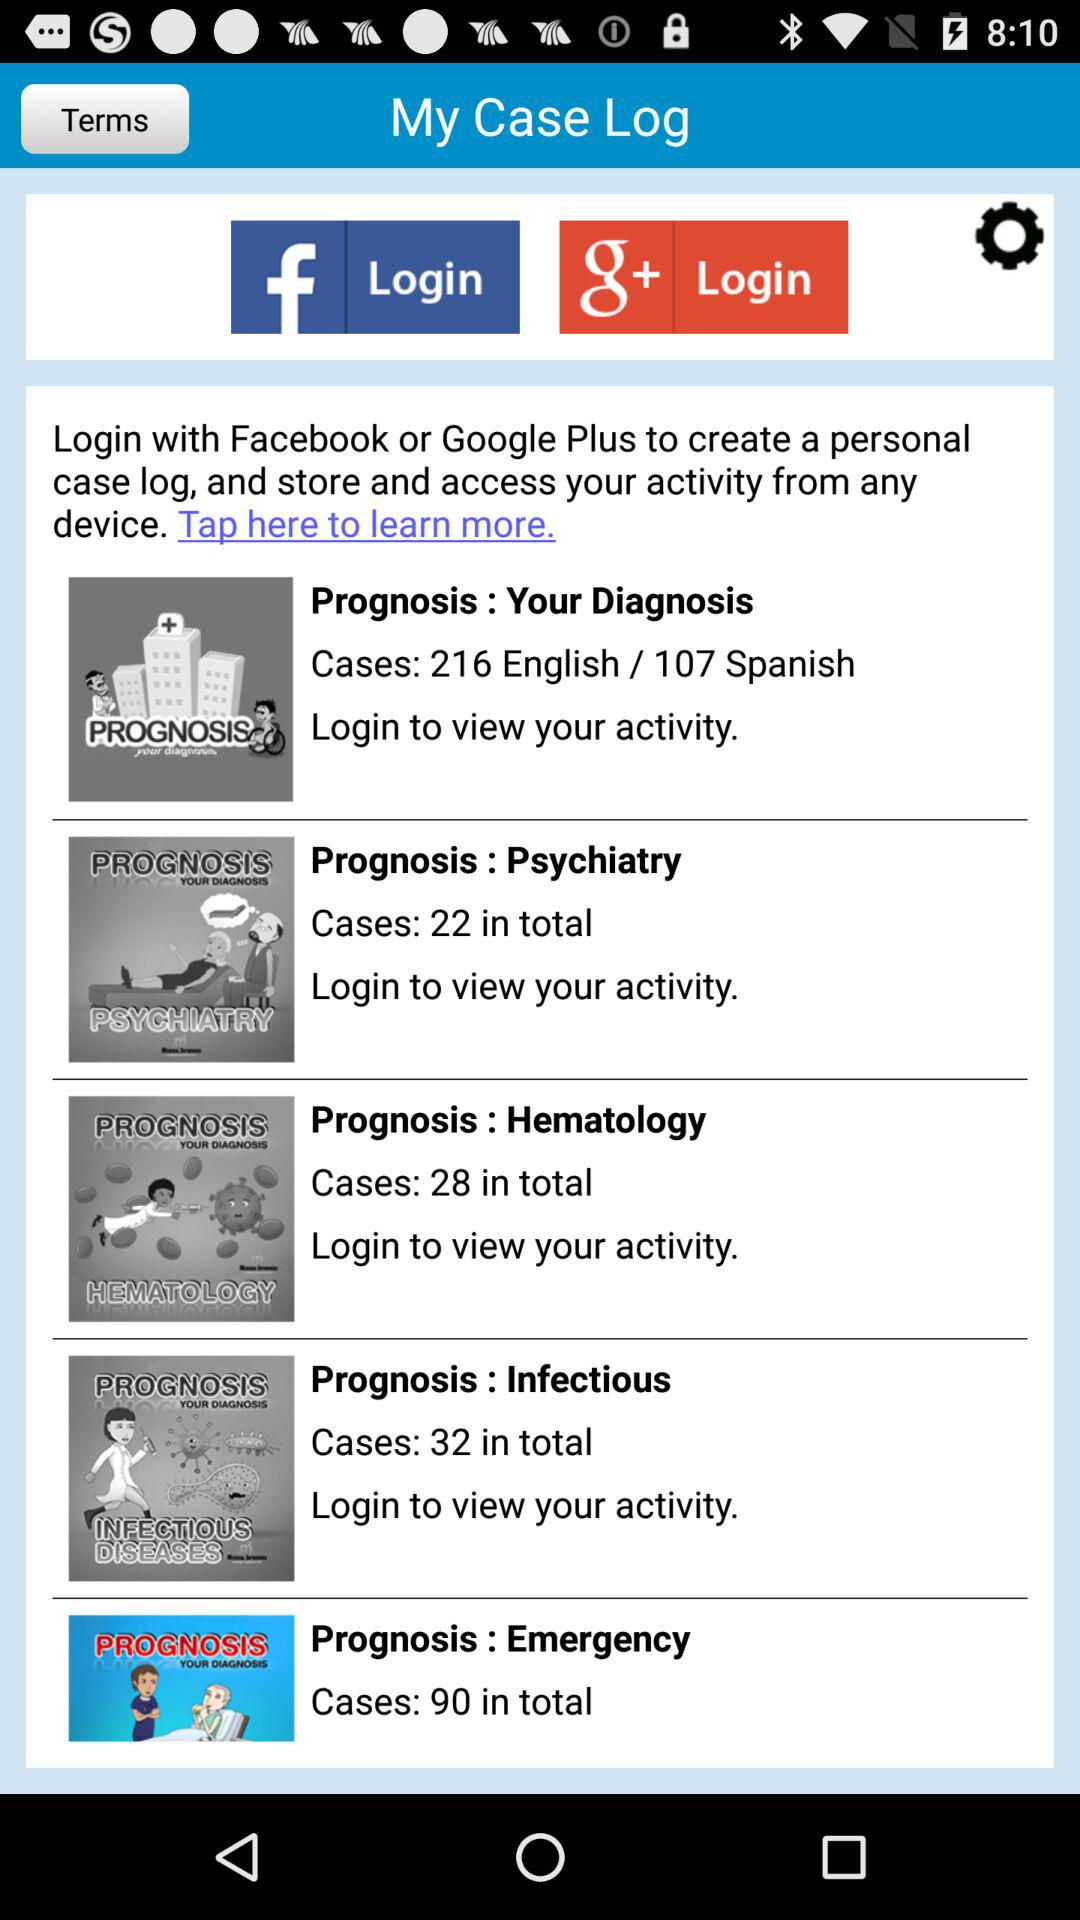How many cases in total are there in an emergency? There are 90 cases in total in an emergency. 